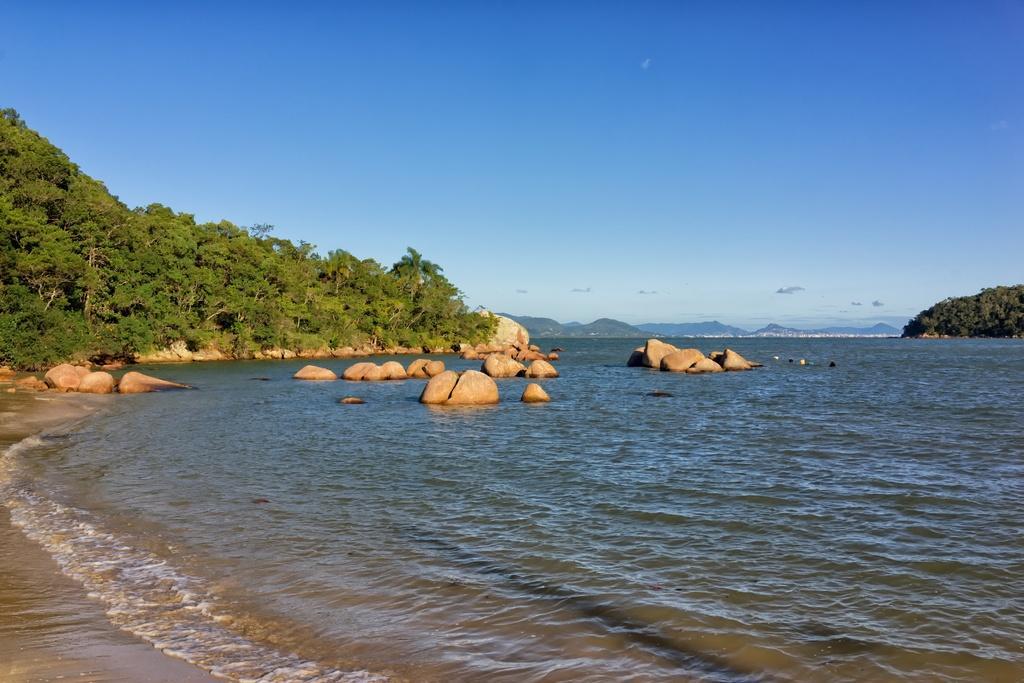Describe this image in one or two sentences. This picture is taken from outside of the city. In this image, on the right side, we can see some trees and plants. In the middle of the image, we can see some stones on the water. On the left side, we can also see some stones, sand, trees, plants. At the top, we can see a sky. In the background, we can see some mountains, at the bottom, we can see water in an ocean. 